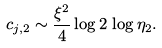<formula> <loc_0><loc_0><loc_500><loc_500>c _ { j , 2 } \sim \frac { \xi ^ { 2 } } { 4 } \log 2 \, \log \eta _ { 2 } .</formula> 